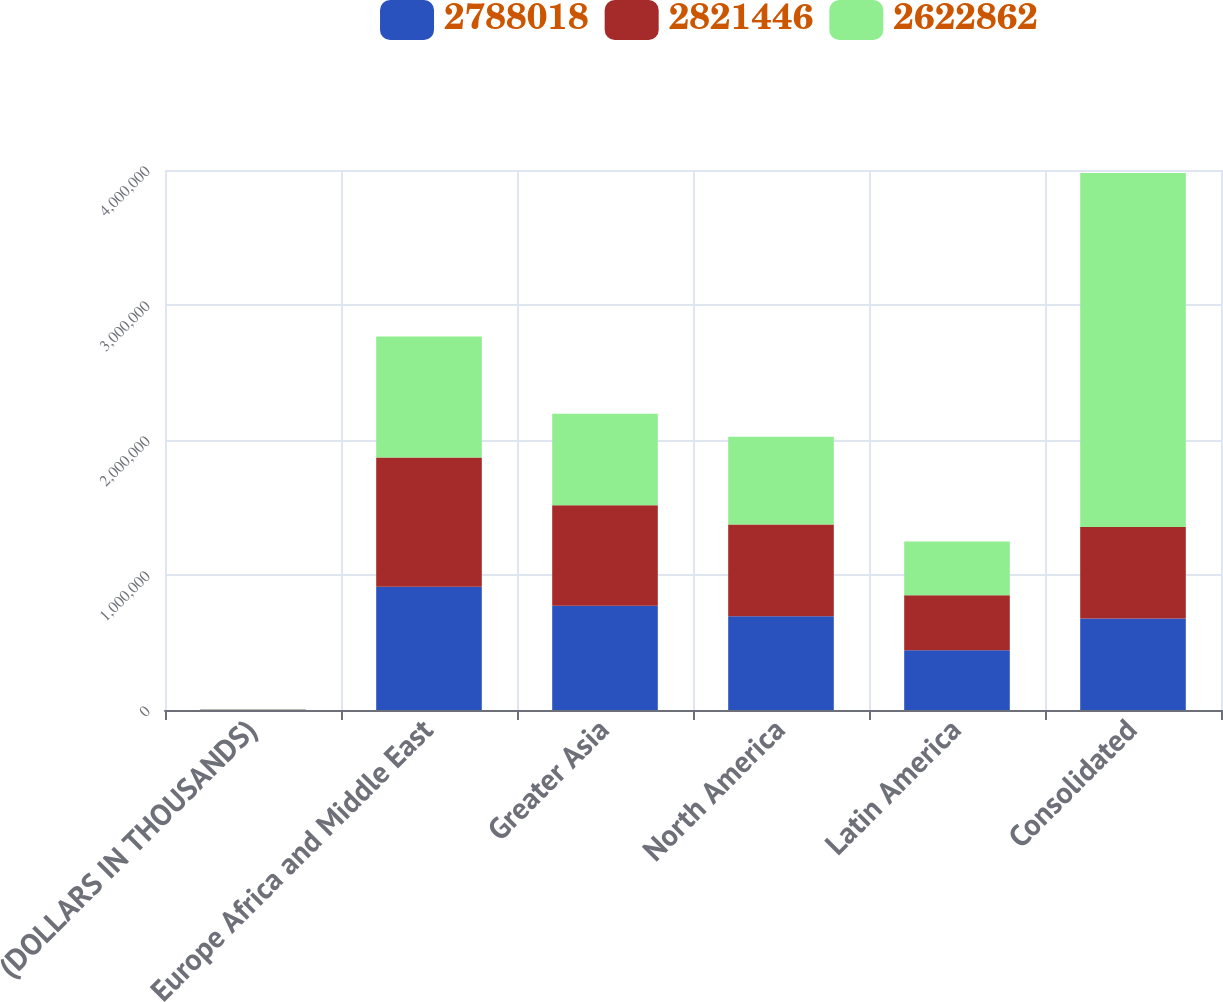<chart> <loc_0><loc_0><loc_500><loc_500><stacked_bar_chart><ecel><fcel>(DOLLARS IN THOUSANDS)<fcel>Europe Africa and Middle East<fcel>Greater Asia<fcel>North America<fcel>Latin America<fcel>Consolidated<nl><fcel>2.78802e+06<fcel>2012<fcel>912768<fcel>771877<fcel>694430<fcel>442371<fcel>677800<nl><fcel>2.82145e+06<fcel>2011<fcel>956977<fcel>744810<fcel>678763<fcel>407468<fcel>677800<nl><fcel>2.62286e+06<fcel>2010<fcel>896647<fcel>676838<fcel>651057<fcel>398320<fcel>2.62286e+06<nl></chart> 